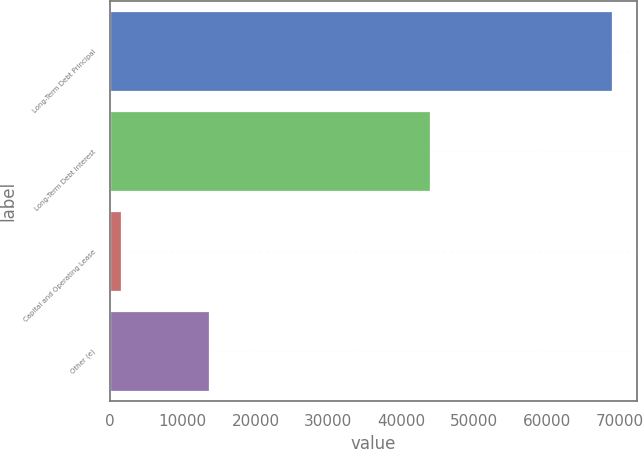Convert chart. <chart><loc_0><loc_0><loc_500><loc_500><bar_chart><fcel>Long-Term Debt Principal<fcel>Long-Term Debt Interest<fcel>Capital and Operating Lease<fcel>Other (e)<nl><fcel>69003<fcel>44013<fcel>1512<fcel>13626<nl></chart> 